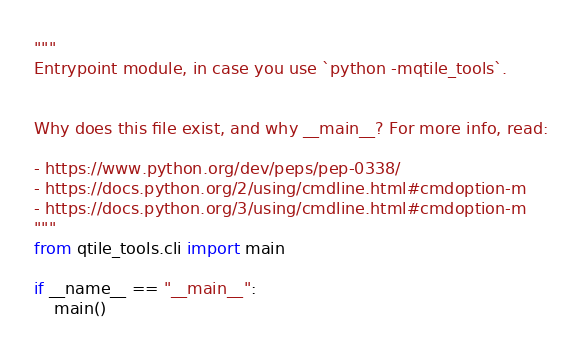Convert code to text. <code><loc_0><loc_0><loc_500><loc_500><_Python_>"""
Entrypoint module, in case you use `python -mqtile_tools`.


Why does this file exist, and why __main__? For more info, read:

- https://www.python.org/dev/peps/pep-0338/
- https://docs.python.org/2/using/cmdline.html#cmdoption-m
- https://docs.python.org/3/using/cmdline.html#cmdoption-m
"""
from qtile_tools.cli import main

if __name__ == "__main__":
    main()
</code> 